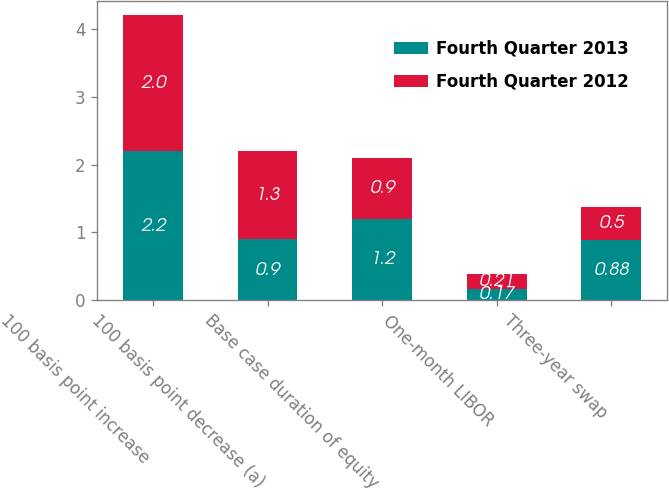Convert chart. <chart><loc_0><loc_0><loc_500><loc_500><stacked_bar_chart><ecel><fcel>100 basis point increase<fcel>100 basis point decrease (a)<fcel>Base case duration of equity<fcel>One-month LIBOR<fcel>Three-year swap<nl><fcel>Fourth Quarter 2013<fcel>2.2<fcel>0.9<fcel>1.2<fcel>0.17<fcel>0.88<nl><fcel>Fourth Quarter 2012<fcel>2<fcel>1.3<fcel>0.9<fcel>0.21<fcel>0.5<nl></chart> 